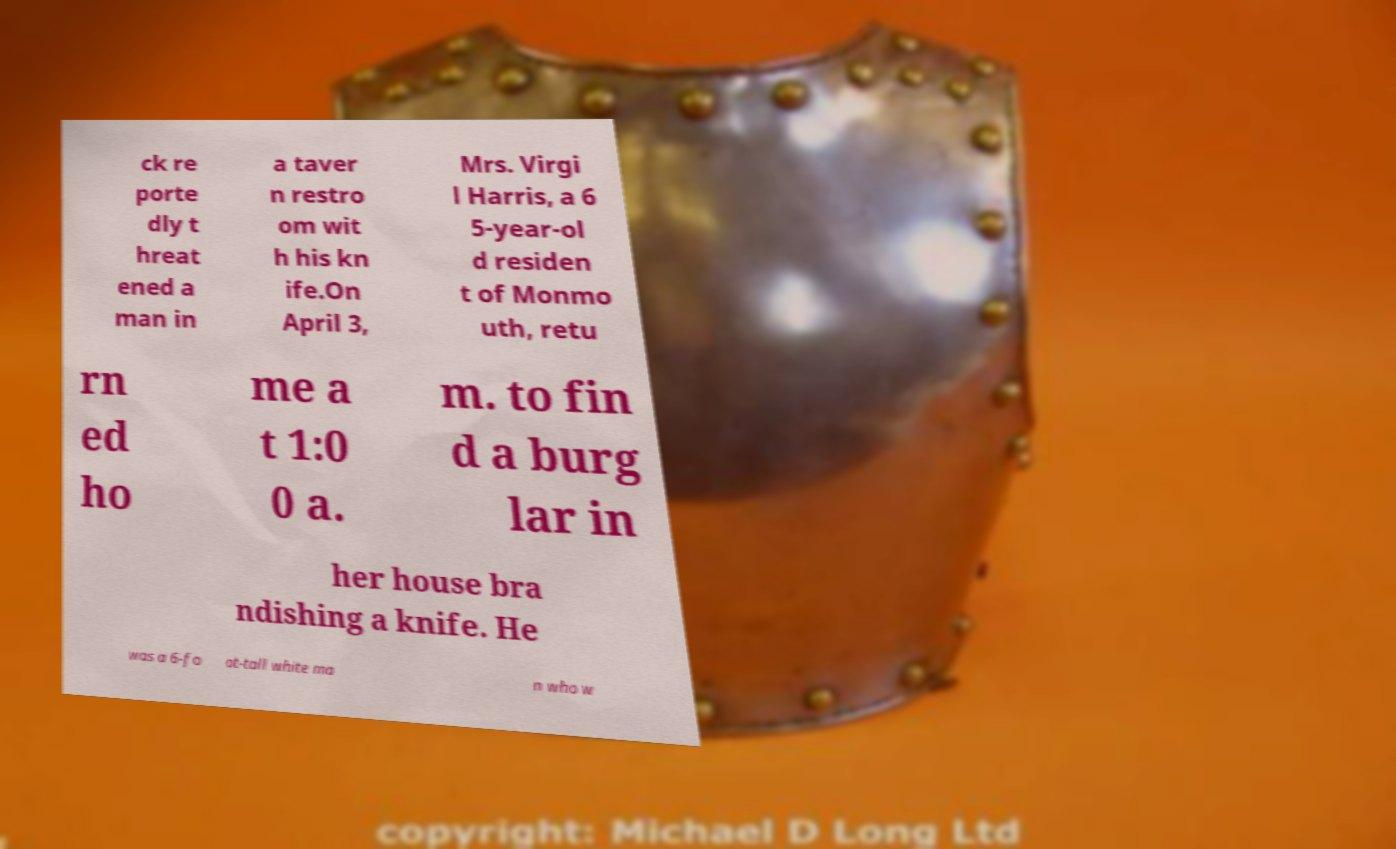Please identify and transcribe the text found in this image. ck re porte dly t hreat ened a man in a taver n restro om wit h his kn ife.On April 3, Mrs. Virgi l Harris, a 6 5-year-ol d residen t of Monmo uth, retu rn ed ho me a t 1:0 0 a. m. to fin d a burg lar in her house bra ndishing a knife. He was a 6-fo ot-tall white ma n who w 